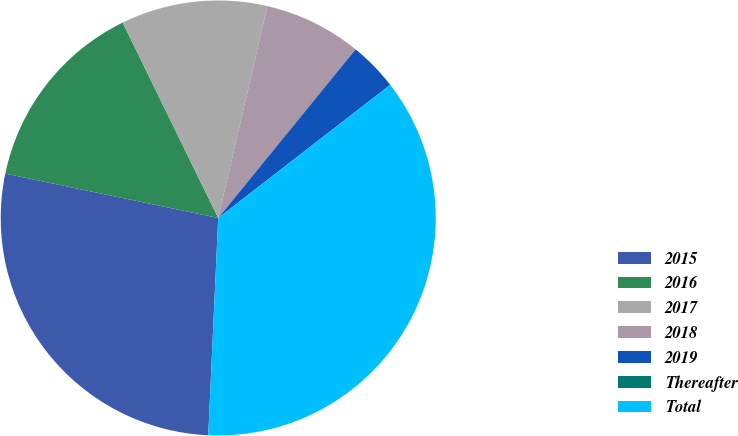Convert chart. <chart><loc_0><loc_0><loc_500><loc_500><pie_chart><fcel>2015<fcel>2016<fcel>2017<fcel>2018<fcel>2019<fcel>Thereafter<fcel>Total<nl><fcel>27.54%<fcel>14.49%<fcel>10.87%<fcel>7.25%<fcel>3.63%<fcel>0.01%<fcel>36.21%<nl></chart> 